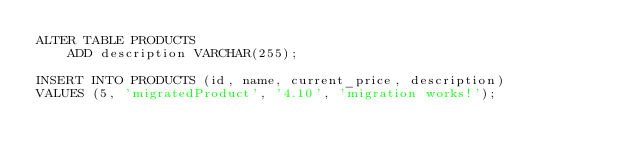<code> <loc_0><loc_0><loc_500><loc_500><_SQL_>ALTER TABLE PRODUCTS
    ADD description VARCHAR(255);

INSERT INTO PRODUCTS (id, name, current_price, description)
VALUES (5, 'migratedProduct', '4.10', 'migration works!');</code> 